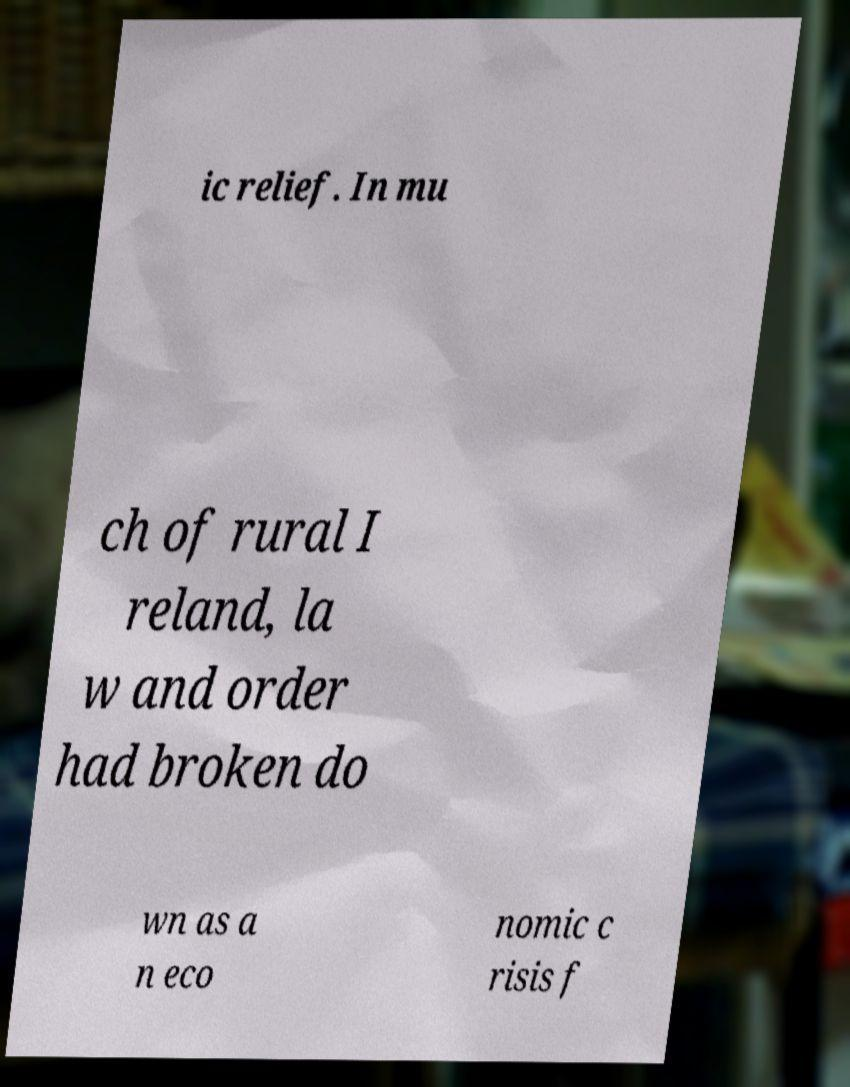I need the written content from this picture converted into text. Can you do that? ic relief. In mu ch of rural I reland, la w and order had broken do wn as a n eco nomic c risis f 